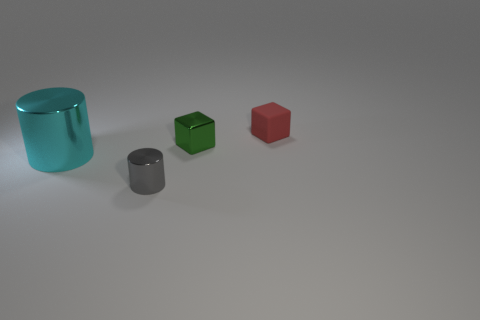Add 2 tiny metallic things. How many objects exist? 6 Subtract 2 cubes. How many cubes are left? 0 Add 1 small matte cylinders. How many small matte cylinders exist? 1 Subtract 1 green cubes. How many objects are left? 3 Subtract all red blocks. Subtract all brown cylinders. How many blocks are left? 1 Subtract all brown cylinders. How many red cubes are left? 1 Subtract all green cubes. Subtract all big green matte balls. How many objects are left? 3 Add 4 blocks. How many blocks are left? 6 